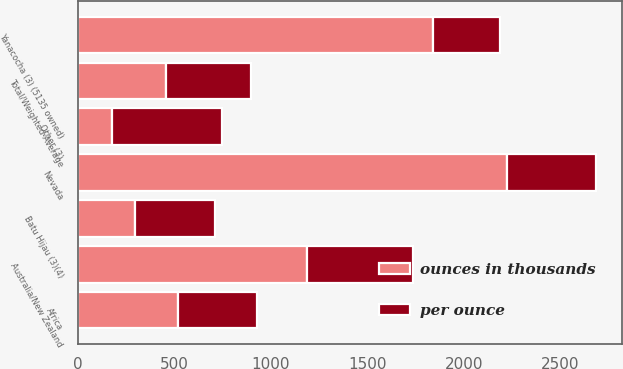Convert chart to OTSL. <chart><loc_0><loc_0><loc_500><loc_500><stacked_bar_chart><ecel><fcel>Nevada<fcel>Yanacocha (3) (5135 owned)<fcel>Australia/New Zealand<fcel>Batu Hijau (3)(4)<fcel>Africa<fcel>Other (3)<fcel>Total/Weighted-Average<nl><fcel>ounces in thousands<fcel>2225<fcel>1843<fcel>1187<fcel>299<fcel>521<fcel>180<fcel>460<nl><fcel>per ounce<fcel>460<fcel>346<fcel>552<fcel>414<fcel>408<fcel>566<fcel>440<nl></chart> 